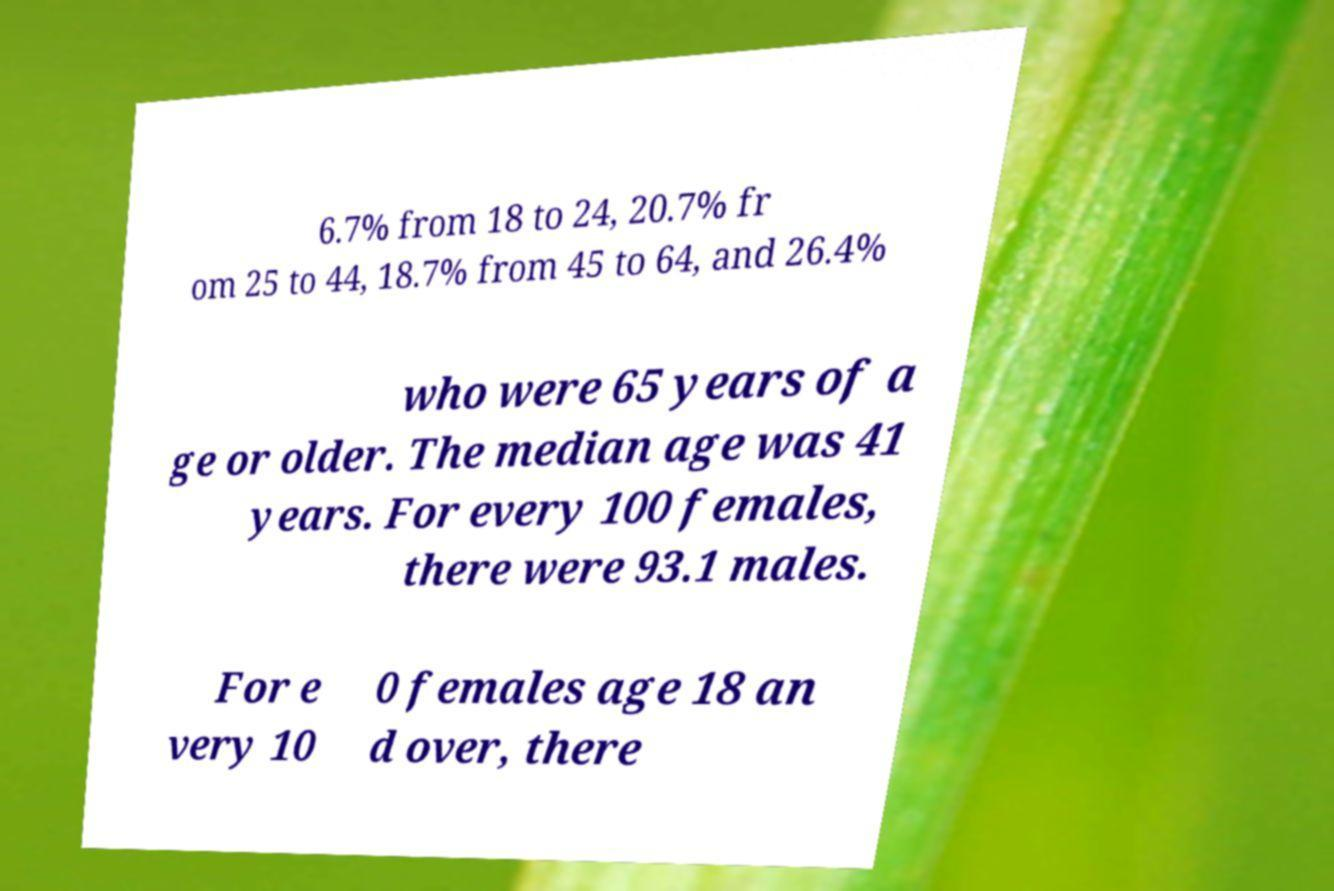For documentation purposes, I need the text within this image transcribed. Could you provide that? 6.7% from 18 to 24, 20.7% fr om 25 to 44, 18.7% from 45 to 64, and 26.4% who were 65 years of a ge or older. The median age was 41 years. For every 100 females, there were 93.1 males. For e very 10 0 females age 18 an d over, there 